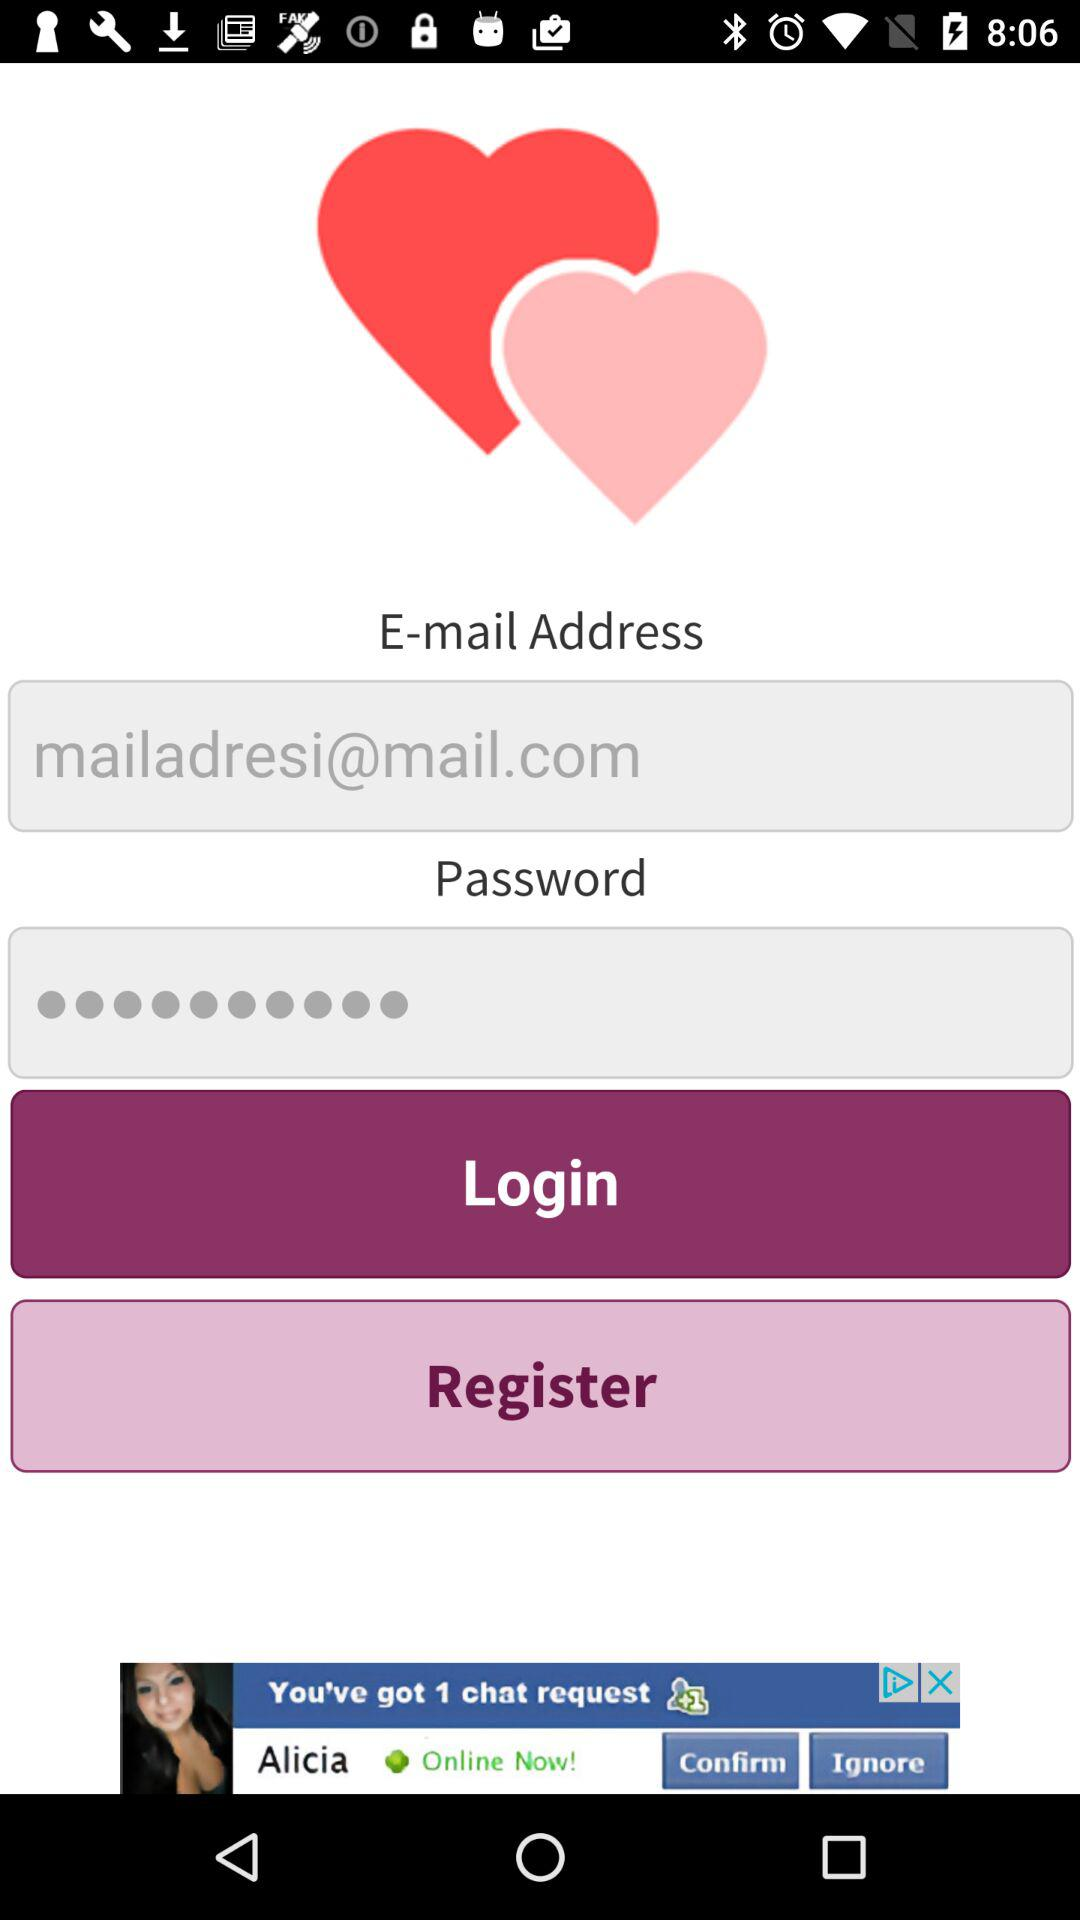What's the email address? The email address is mailadresi@mail.com. 